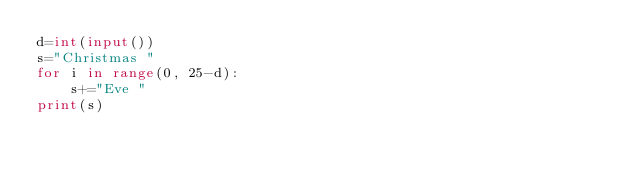<code> <loc_0><loc_0><loc_500><loc_500><_Python_>d=int(input())
s="Christmas "
for i in range(0, 25-d):
    s+="Eve "
print(s)</code> 